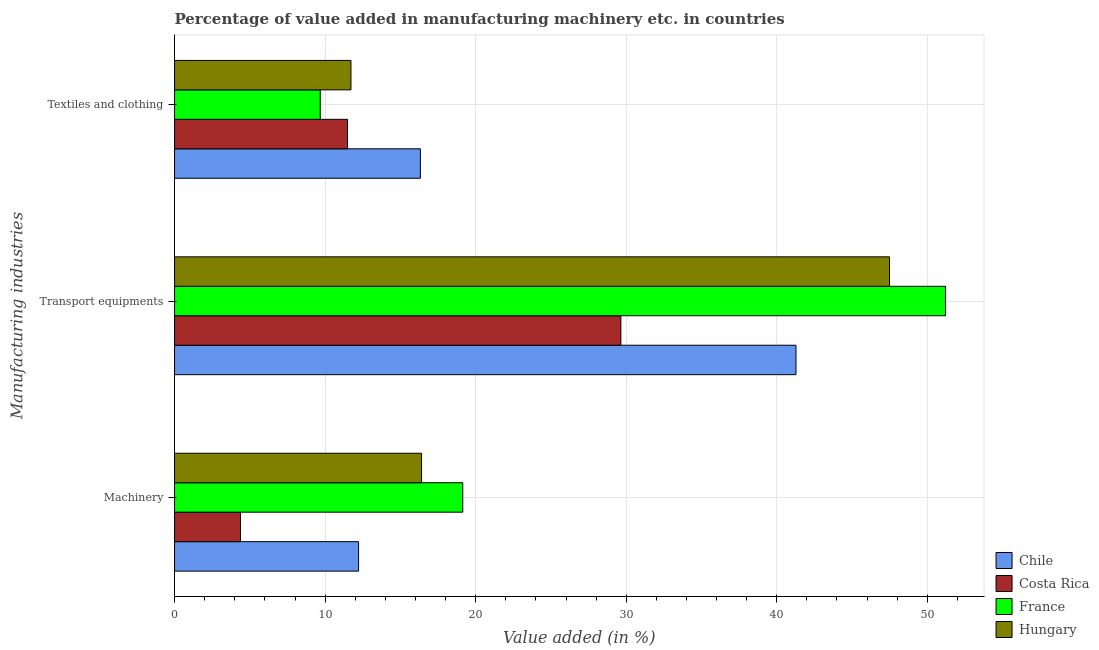How many different coloured bars are there?
Offer a terse response. 4. How many groups of bars are there?
Make the answer very short. 3. Are the number of bars per tick equal to the number of legend labels?
Make the answer very short. Yes. How many bars are there on the 3rd tick from the top?
Your answer should be very brief. 4. How many bars are there on the 2nd tick from the bottom?
Give a very brief answer. 4. What is the label of the 3rd group of bars from the top?
Offer a very short reply. Machinery. What is the value added in manufacturing machinery in France?
Your answer should be very brief. 19.14. Across all countries, what is the maximum value added in manufacturing transport equipments?
Provide a short and direct response. 51.21. Across all countries, what is the minimum value added in manufacturing transport equipments?
Make the answer very short. 29.64. In which country was the value added in manufacturing transport equipments minimum?
Offer a very short reply. Costa Rica. What is the total value added in manufacturing machinery in the graph?
Give a very brief answer. 52.15. What is the difference between the value added in manufacturing textile and clothing in France and that in Costa Rica?
Ensure brevity in your answer.  -1.81. What is the difference between the value added in manufacturing textile and clothing in France and the value added in manufacturing transport equipments in Hungary?
Make the answer very short. -37.81. What is the average value added in manufacturing transport equipments per country?
Ensure brevity in your answer.  42.4. What is the difference between the value added in manufacturing textile and clothing and value added in manufacturing machinery in Costa Rica?
Provide a succinct answer. 7.11. In how many countries, is the value added in manufacturing textile and clothing greater than 42 %?
Your response must be concise. 0. What is the ratio of the value added in manufacturing textile and clothing in Hungary to that in Chile?
Ensure brevity in your answer.  0.72. Is the value added in manufacturing textile and clothing in France less than that in Chile?
Your answer should be compact. Yes. What is the difference between the highest and the second highest value added in manufacturing machinery?
Provide a short and direct response. 2.74. What is the difference between the highest and the lowest value added in manufacturing transport equipments?
Your response must be concise. 21.56. Is the sum of the value added in manufacturing transport equipments in France and Hungary greater than the maximum value added in manufacturing textile and clothing across all countries?
Ensure brevity in your answer.  Yes. How many bars are there?
Offer a terse response. 12. What is the difference between two consecutive major ticks on the X-axis?
Your answer should be compact. 10. Are the values on the major ticks of X-axis written in scientific E-notation?
Your answer should be very brief. No. Does the graph contain grids?
Provide a succinct answer. Yes. Where does the legend appear in the graph?
Offer a very short reply. Bottom right. How are the legend labels stacked?
Ensure brevity in your answer.  Vertical. What is the title of the graph?
Provide a succinct answer. Percentage of value added in manufacturing machinery etc. in countries. Does "Cayman Islands" appear as one of the legend labels in the graph?
Make the answer very short. No. What is the label or title of the X-axis?
Make the answer very short. Value added (in %). What is the label or title of the Y-axis?
Your answer should be very brief. Manufacturing industries. What is the Value added (in %) of Chile in Machinery?
Provide a short and direct response. 12.22. What is the Value added (in %) of Costa Rica in Machinery?
Provide a succinct answer. 4.38. What is the Value added (in %) in France in Machinery?
Your response must be concise. 19.14. What is the Value added (in %) in Hungary in Machinery?
Provide a succinct answer. 16.41. What is the Value added (in %) in Chile in Transport equipments?
Your response must be concise. 41.28. What is the Value added (in %) of Costa Rica in Transport equipments?
Give a very brief answer. 29.64. What is the Value added (in %) of France in Transport equipments?
Keep it short and to the point. 51.21. What is the Value added (in %) in Hungary in Transport equipments?
Ensure brevity in your answer.  47.49. What is the Value added (in %) in Chile in Textiles and clothing?
Provide a succinct answer. 16.33. What is the Value added (in %) in Costa Rica in Textiles and clothing?
Make the answer very short. 11.49. What is the Value added (in %) of France in Textiles and clothing?
Make the answer very short. 9.68. What is the Value added (in %) of Hungary in Textiles and clothing?
Provide a short and direct response. 11.72. Across all Manufacturing industries, what is the maximum Value added (in %) of Chile?
Keep it short and to the point. 41.28. Across all Manufacturing industries, what is the maximum Value added (in %) in Costa Rica?
Your response must be concise. 29.64. Across all Manufacturing industries, what is the maximum Value added (in %) of France?
Your answer should be compact. 51.21. Across all Manufacturing industries, what is the maximum Value added (in %) of Hungary?
Your answer should be compact. 47.49. Across all Manufacturing industries, what is the minimum Value added (in %) in Chile?
Your answer should be very brief. 12.22. Across all Manufacturing industries, what is the minimum Value added (in %) in Costa Rica?
Ensure brevity in your answer.  4.38. Across all Manufacturing industries, what is the minimum Value added (in %) of France?
Provide a succinct answer. 9.68. Across all Manufacturing industries, what is the minimum Value added (in %) in Hungary?
Make the answer very short. 11.72. What is the total Value added (in %) of Chile in the graph?
Your response must be concise. 69.83. What is the total Value added (in %) of Costa Rica in the graph?
Provide a succinct answer. 45.51. What is the total Value added (in %) of France in the graph?
Ensure brevity in your answer.  80.03. What is the total Value added (in %) of Hungary in the graph?
Ensure brevity in your answer.  75.61. What is the difference between the Value added (in %) in Chile in Machinery and that in Transport equipments?
Provide a short and direct response. -29.05. What is the difference between the Value added (in %) in Costa Rica in Machinery and that in Transport equipments?
Your response must be concise. -25.26. What is the difference between the Value added (in %) in France in Machinery and that in Transport equipments?
Keep it short and to the point. -32.06. What is the difference between the Value added (in %) in Hungary in Machinery and that in Transport equipments?
Provide a succinct answer. -31.08. What is the difference between the Value added (in %) in Chile in Machinery and that in Textiles and clothing?
Your answer should be compact. -4.11. What is the difference between the Value added (in %) of Costa Rica in Machinery and that in Textiles and clothing?
Offer a terse response. -7.11. What is the difference between the Value added (in %) of France in Machinery and that in Textiles and clothing?
Keep it short and to the point. 9.47. What is the difference between the Value added (in %) in Hungary in Machinery and that in Textiles and clothing?
Ensure brevity in your answer.  4.69. What is the difference between the Value added (in %) of Chile in Transport equipments and that in Textiles and clothing?
Provide a short and direct response. 24.95. What is the difference between the Value added (in %) of Costa Rica in Transport equipments and that in Textiles and clothing?
Your answer should be compact. 18.15. What is the difference between the Value added (in %) of France in Transport equipments and that in Textiles and clothing?
Make the answer very short. 41.53. What is the difference between the Value added (in %) in Hungary in Transport equipments and that in Textiles and clothing?
Your answer should be compact. 35.77. What is the difference between the Value added (in %) of Chile in Machinery and the Value added (in %) of Costa Rica in Transport equipments?
Offer a very short reply. -17.42. What is the difference between the Value added (in %) in Chile in Machinery and the Value added (in %) in France in Transport equipments?
Provide a succinct answer. -38.98. What is the difference between the Value added (in %) in Chile in Machinery and the Value added (in %) in Hungary in Transport equipments?
Provide a short and direct response. -35.27. What is the difference between the Value added (in %) in Costa Rica in Machinery and the Value added (in %) in France in Transport equipments?
Your response must be concise. -46.83. What is the difference between the Value added (in %) in Costa Rica in Machinery and the Value added (in %) in Hungary in Transport equipments?
Your answer should be compact. -43.11. What is the difference between the Value added (in %) in France in Machinery and the Value added (in %) in Hungary in Transport equipments?
Provide a short and direct response. -28.35. What is the difference between the Value added (in %) of Chile in Machinery and the Value added (in %) of Costa Rica in Textiles and clothing?
Provide a short and direct response. 0.73. What is the difference between the Value added (in %) of Chile in Machinery and the Value added (in %) of France in Textiles and clothing?
Offer a very short reply. 2.55. What is the difference between the Value added (in %) in Chile in Machinery and the Value added (in %) in Hungary in Textiles and clothing?
Keep it short and to the point. 0.51. What is the difference between the Value added (in %) of Costa Rica in Machinery and the Value added (in %) of France in Textiles and clothing?
Make the answer very short. -5.3. What is the difference between the Value added (in %) in Costa Rica in Machinery and the Value added (in %) in Hungary in Textiles and clothing?
Give a very brief answer. -7.34. What is the difference between the Value added (in %) in France in Machinery and the Value added (in %) in Hungary in Textiles and clothing?
Offer a very short reply. 7.43. What is the difference between the Value added (in %) of Chile in Transport equipments and the Value added (in %) of Costa Rica in Textiles and clothing?
Offer a very short reply. 29.79. What is the difference between the Value added (in %) in Chile in Transport equipments and the Value added (in %) in France in Textiles and clothing?
Make the answer very short. 31.6. What is the difference between the Value added (in %) of Chile in Transport equipments and the Value added (in %) of Hungary in Textiles and clothing?
Give a very brief answer. 29.56. What is the difference between the Value added (in %) of Costa Rica in Transport equipments and the Value added (in %) of France in Textiles and clothing?
Offer a very short reply. 19.97. What is the difference between the Value added (in %) of Costa Rica in Transport equipments and the Value added (in %) of Hungary in Textiles and clothing?
Make the answer very short. 17.93. What is the difference between the Value added (in %) of France in Transport equipments and the Value added (in %) of Hungary in Textiles and clothing?
Provide a short and direct response. 39.49. What is the average Value added (in %) of Chile per Manufacturing industries?
Provide a short and direct response. 23.28. What is the average Value added (in %) in Costa Rica per Manufacturing industries?
Make the answer very short. 15.17. What is the average Value added (in %) of France per Manufacturing industries?
Offer a very short reply. 26.68. What is the average Value added (in %) in Hungary per Manufacturing industries?
Offer a terse response. 25.2. What is the difference between the Value added (in %) in Chile and Value added (in %) in Costa Rica in Machinery?
Your answer should be compact. 7.84. What is the difference between the Value added (in %) in Chile and Value added (in %) in France in Machinery?
Give a very brief answer. -6.92. What is the difference between the Value added (in %) in Chile and Value added (in %) in Hungary in Machinery?
Keep it short and to the point. -4.18. What is the difference between the Value added (in %) in Costa Rica and Value added (in %) in France in Machinery?
Offer a terse response. -14.76. What is the difference between the Value added (in %) in Costa Rica and Value added (in %) in Hungary in Machinery?
Your answer should be compact. -12.03. What is the difference between the Value added (in %) of France and Value added (in %) of Hungary in Machinery?
Make the answer very short. 2.74. What is the difference between the Value added (in %) in Chile and Value added (in %) in Costa Rica in Transport equipments?
Keep it short and to the point. 11.63. What is the difference between the Value added (in %) in Chile and Value added (in %) in France in Transport equipments?
Make the answer very short. -9.93. What is the difference between the Value added (in %) in Chile and Value added (in %) in Hungary in Transport equipments?
Offer a terse response. -6.21. What is the difference between the Value added (in %) in Costa Rica and Value added (in %) in France in Transport equipments?
Your answer should be compact. -21.56. What is the difference between the Value added (in %) of Costa Rica and Value added (in %) of Hungary in Transport equipments?
Provide a short and direct response. -17.85. What is the difference between the Value added (in %) in France and Value added (in %) in Hungary in Transport equipments?
Ensure brevity in your answer.  3.72. What is the difference between the Value added (in %) of Chile and Value added (in %) of Costa Rica in Textiles and clothing?
Provide a succinct answer. 4.84. What is the difference between the Value added (in %) in Chile and Value added (in %) in France in Textiles and clothing?
Give a very brief answer. 6.65. What is the difference between the Value added (in %) in Chile and Value added (in %) in Hungary in Textiles and clothing?
Ensure brevity in your answer.  4.61. What is the difference between the Value added (in %) of Costa Rica and Value added (in %) of France in Textiles and clothing?
Your answer should be very brief. 1.81. What is the difference between the Value added (in %) in Costa Rica and Value added (in %) in Hungary in Textiles and clothing?
Ensure brevity in your answer.  -0.23. What is the difference between the Value added (in %) of France and Value added (in %) of Hungary in Textiles and clothing?
Keep it short and to the point. -2.04. What is the ratio of the Value added (in %) in Chile in Machinery to that in Transport equipments?
Ensure brevity in your answer.  0.3. What is the ratio of the Value added (in %) of Costa Rica in Machinery to that in Transport equipments?
Provide a succinct answer. 0.15. What is the ratio of the Value added (in %) in France in Machinery to that in Transport equipments?
Ensure brevity in your answer.  0.37. What is the ratio of the Value added (in %) of Hungary in Machinery to that in Transport equipments?
Offer a very short reply. 0.35. What is the ratio of the Value added (in %) in Chile in Machinery to that in Textiles and clothing?
Offer a very short reply. 0.75. What is the ratio of the Value added (in %) of Costa Rica in Machinery to that in Textiles and clothing?
Your answer should be very brief. 0.38. What is the ratio of the Value added (in %) of France in Machinery to that in Textiles and clothing?
Your answer should be compact. 1.98. What is the ratio of the Value added (in %) of Hungary in Machinery to that in Textiles and clothing?
Provide a short and direct response. 1.4. What is the ratio of the Value added (in %) of Chile in Transport equipments to that in Textiles and clothing?
Your answer should be very brief. 2.53. What is the ratio of the Value added (in %) in Costa Rica in Transport equipments to that in Textiles and clothing?
Make the answer very short. 2.58. What is the ratio of the Value added (in %) of France in Transport equipments to that in Textiles and clothing?
Your response must be concise. 5.29. What is the ratio of the Value added (in %) in Hungary in Transport equipments to that in Textiles and clothing?
Your response must be concise. 4.05. What is the difference between the highest and the second highest Value added (in %) of Chile?
Offer a very short reply. 24.95. What is the difference between the highest and the second highest Value added (in %) in Costa Rica?
Provide a succinct answer. 18.15. What is the difference between the highest and the second highest Value added (in %) in France?
Ensure brevity in your answer.  32.06. What is the difference between the highest and the second highest Value added (in %) in Hungary?
Keep it short and to the point. 31.08. What is the difference between the highest and the lowest Value added (in %) in Chile?
Give a very brief answer. 29.05. What is the difference between the highest and the lowest Value added (in %) in Costa Rica?
Offer a very short reply. 25.26. What is the difference between the highest and the lowest Value added (in %) of France?
Provide a short and direct response. 41.53. What is the difference between the highest and the lowest Value added (in %) of Hungary?
Give a very brief answer. 35.77. 